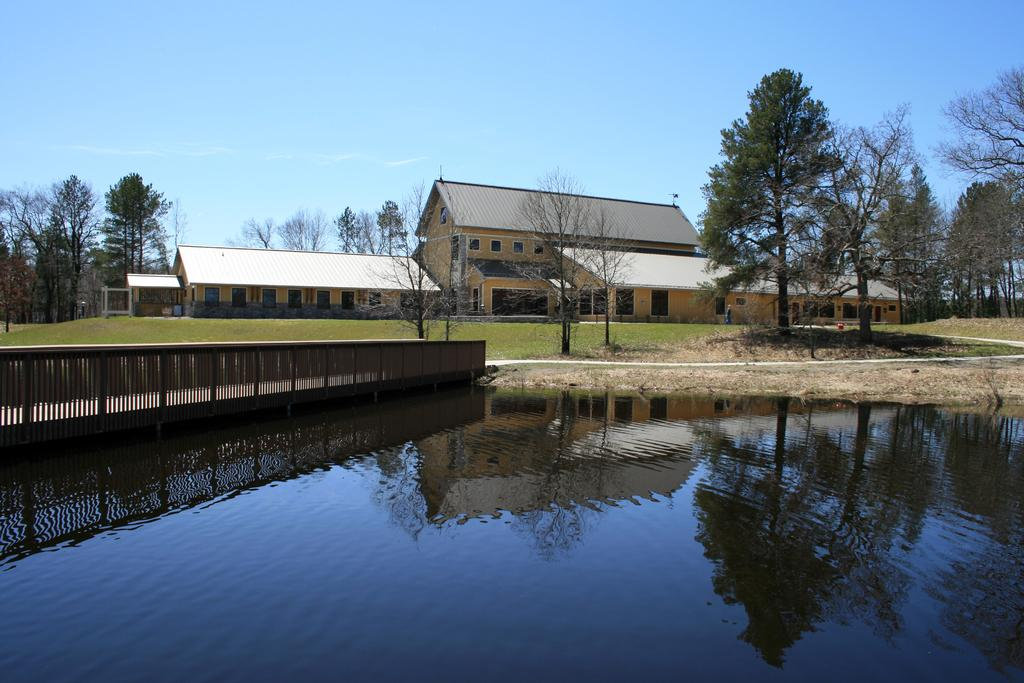What is located at the front of the image? There is water in the front of the image. What can be seen in the center of the image? There is a fence in the center of the image. What type of vegetation is visible in the background of the image? There are trees in the background of the image. What type of structures can be seen in the background of the image? There are buildings in the background of the image. What type of ground surface is present in the image? There is grass on the ground in the image. What type of metal is used to create the wish-granting magic in the image? There is no mention of magic or wishes in the image, and no metal is visible. 